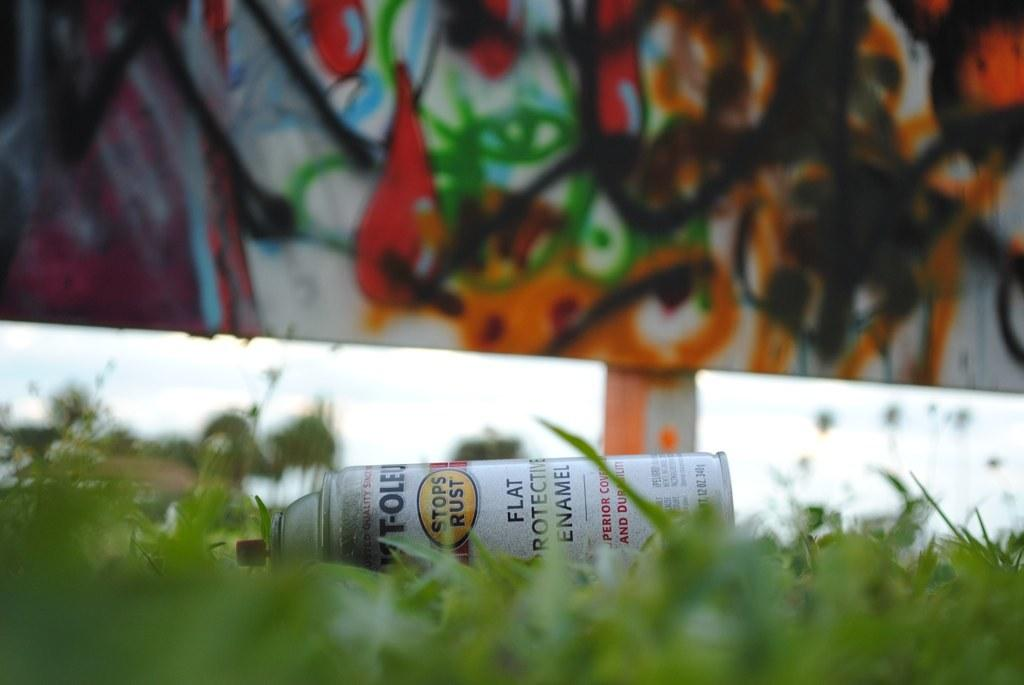<image>
Relay a brief, clear account of the picture shown. A can of rust stopper with Flat Protective Enamel is lying on the ground. 